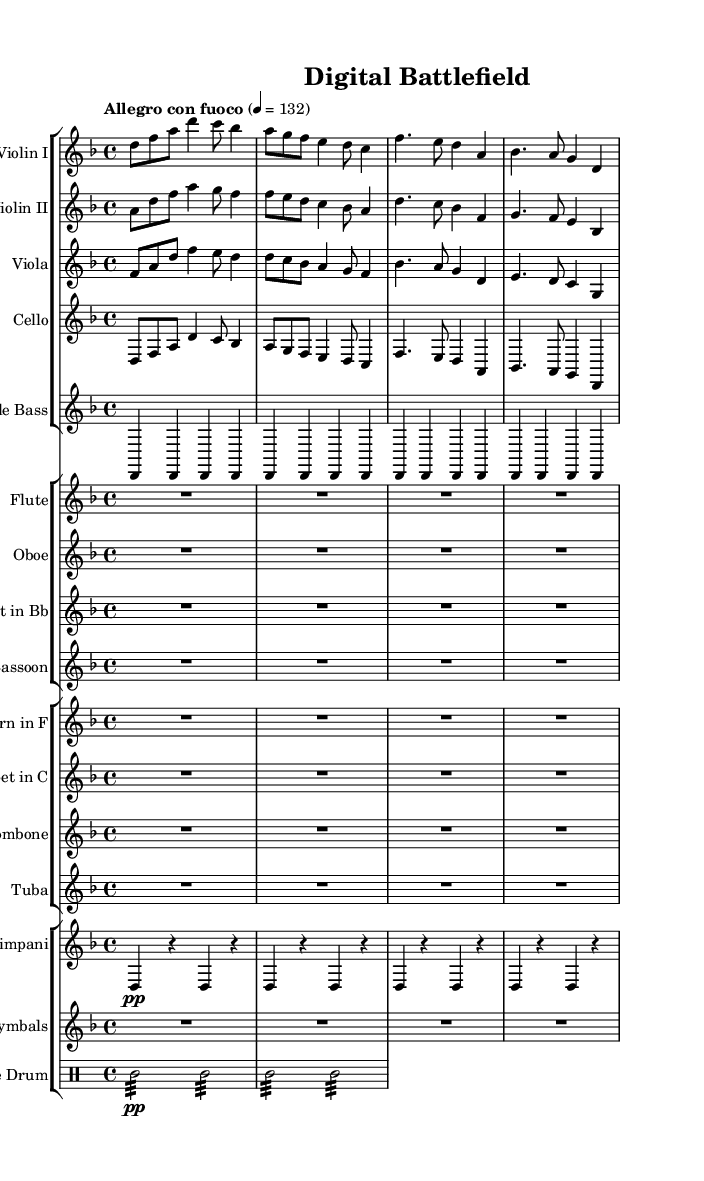What is the key signature of this music? The key signature is D minor, indicated by one flat (B flat) at the beginning of the staff.
Answer: D minor What is the time signature of this music? The time signature is 4/4, indicated by the fraction at the beginning which represents four beats in a measure.
Answer: 4/4 What is the tempo marking of this symphony? The tempo marking is "Allegro con fuoco," which indicates a fast, fiery pace, specified by the words written above the staff.
Answer: Allegro con fuoco Which instruments are featured in the violins section? The violins section includes Violin I and Violin II, as indicated by their respective staff labels.
Answer: Violin I and Violin II What rhythm is used in the snare drum? The rhythm in the snare drum is a repeated tremolo of sixteenth notes, as shown by the notation and the repeated tremolo markings.
Answer: Tremolo How does the dynamics change throughout the cello part? The cello part includes dynamic markings such as "p" for piano (soft) and "f" for forte (loud), which indicate shifts in volume during the performance.
Answer: Varies (from p to f) What is the overall mood conveyed by the music? The overall mood is tense and dramatic, reflecting the theme of cyber warfare, as indicated by the fast tempo, use of minor key, and the nature of the rhythmic patterns.
Answer: Tense and dramatic 